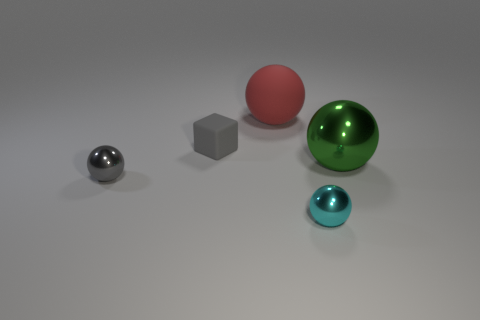There is a rubber cube; is its color the same as the metallic sphere left of the cyan thing?
Provide a short and direct response. Yes. How many large shiny balls are the same color as the small matte cube?
Offer a terse response. 0. There is a small thing that is the same material as the red sphere; what shape is it?
Offer a terse response. Cube. How big is the gray thing behind the large green metal ball?
Make the answer very short. Small. Are there an equal number of tiny metal objects behind the gray rubber thing and metallic objects on the left side of the green object?
Provide a succinct answer. No. What color is the small object that is behind the big ball that is in front of the large ball that is behind the small block?
Provide a succinct answer. Gray. How many small objects are both to the left of the big matte ball and in front of the small gray matte thing?
Give a very brief answer. 1. Does the shiny object that is on the left side of the red sphere have the same color as the small thing that is behind the gray sphere?
Provide a succinct answer. Yes. There is a red matte thing that is the same shape as the big green thing; what size is it?
Your answer should be compact. Large. Are there any gray objects left of the cyan thing?
Give a very brief answer. Yes. 